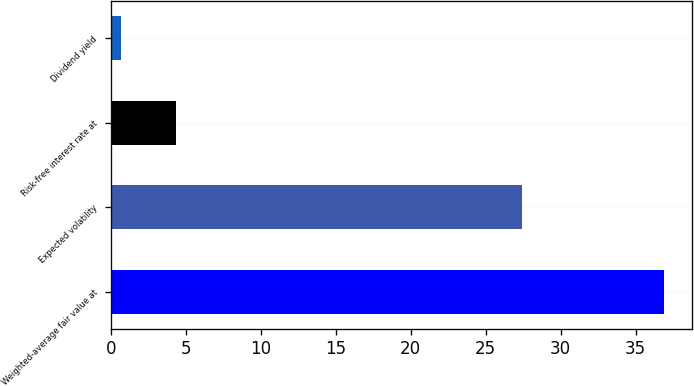<chart> <loc_0><loc_0><loc_500><loc_500><bar_chart><fcel>Weighted-average fair value at<fcel>Expected volatility<fcel>Risk-free interest rate at<fcel>Dividend yield<nl><fcel>36.91<fcel>27.4<fcel>4.32<fcel>0.7<nl></chart> 